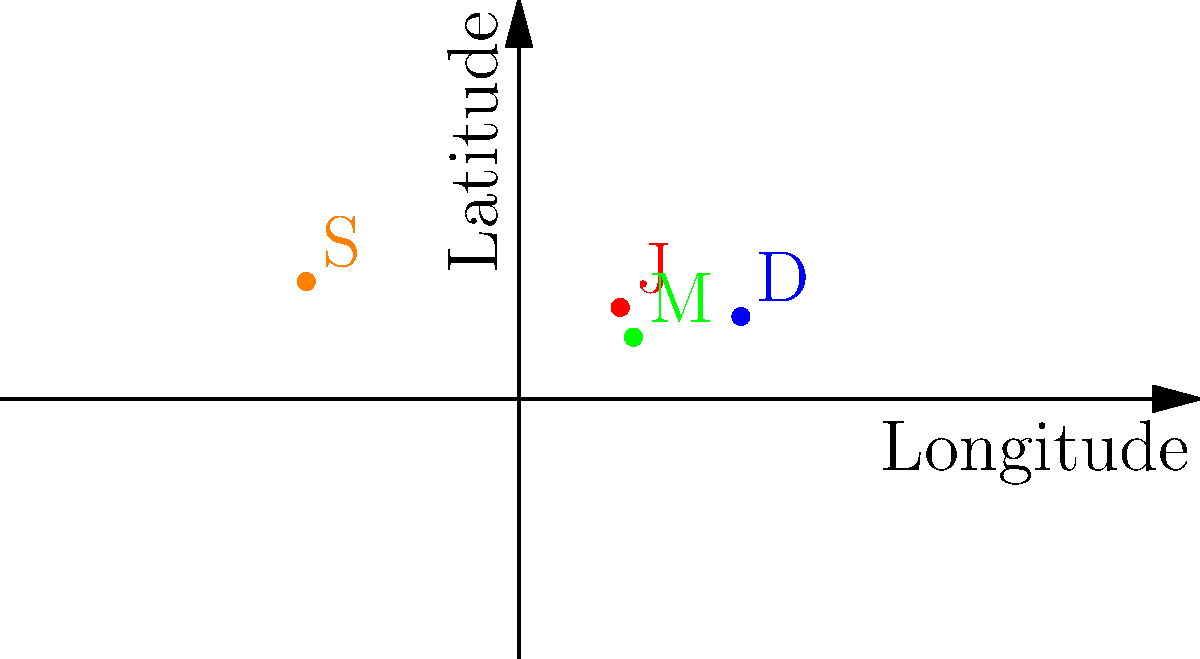On the world map above, four spiritual centers are marked with colored dots: Jerusalem (J), Mecca (M), Delhi (D), and Stonewall Inn in New York (S). Which spiritual center is located at coordinates (39.8262°E, 21.4225°N), and what religion or movement is it most closely associated with? To answer this question, we need to follow these steps:

1. Identify the coordinates given in the question: (39.8262°E, 21.4225°N).
2. Locate this point on the map provided.
3. Determine which colored dot corresponds to these coordinates.
4. Recall the spiritual center associated with that dot.
5. Identify the religion or movement most closely associated with this spiritual center.

Looking at the map:
- The red dot (J) is Jerusalem, important in Judaism, Christianity, and Islam.
- The green dot (M) is at (39.8262°E, 21.4225°N), which matches the coordinates in the question.
- The blue dot (D) is Delhi, significant in Hinduism and Sikhism.
- The orange dot (S) is Stonewall Inn in New York, important for the LGBTQ+ rights movement.

The green dot (M) represents Mecca, which is the holiest city in Islam. It is the birthplace of Prophet Muhammad and the site of the Kaaba, towards which Muslims pray.

Therefore, the spiritual center located at (39.8262°E, 21.4225°N) is Mecca, and it is most closely associated with Islam.
Answer: Mecca; Islam 